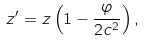Convert formula to latex. <formula><loc_0><loc_0><loc_500><loc_500>z ^ { \prime } = z \left ( 1 - \frac { \varphi } { 2 c ^ { 2 } } \right ) ,</formula> 